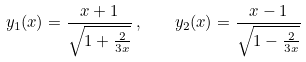<formula> <loc_0><loc_0><loc_500><loc_500>y _ { 1 } ( x ) = \frac { x + 1 } { \sqrt { 1 + \frac { 2 } { 3 x } } } \, , \quad y _ { 2 } ( x ) = \frac { x - 1 } { \sqrt { 1 - \frac { 2 } { 3 x } } }</formula> 